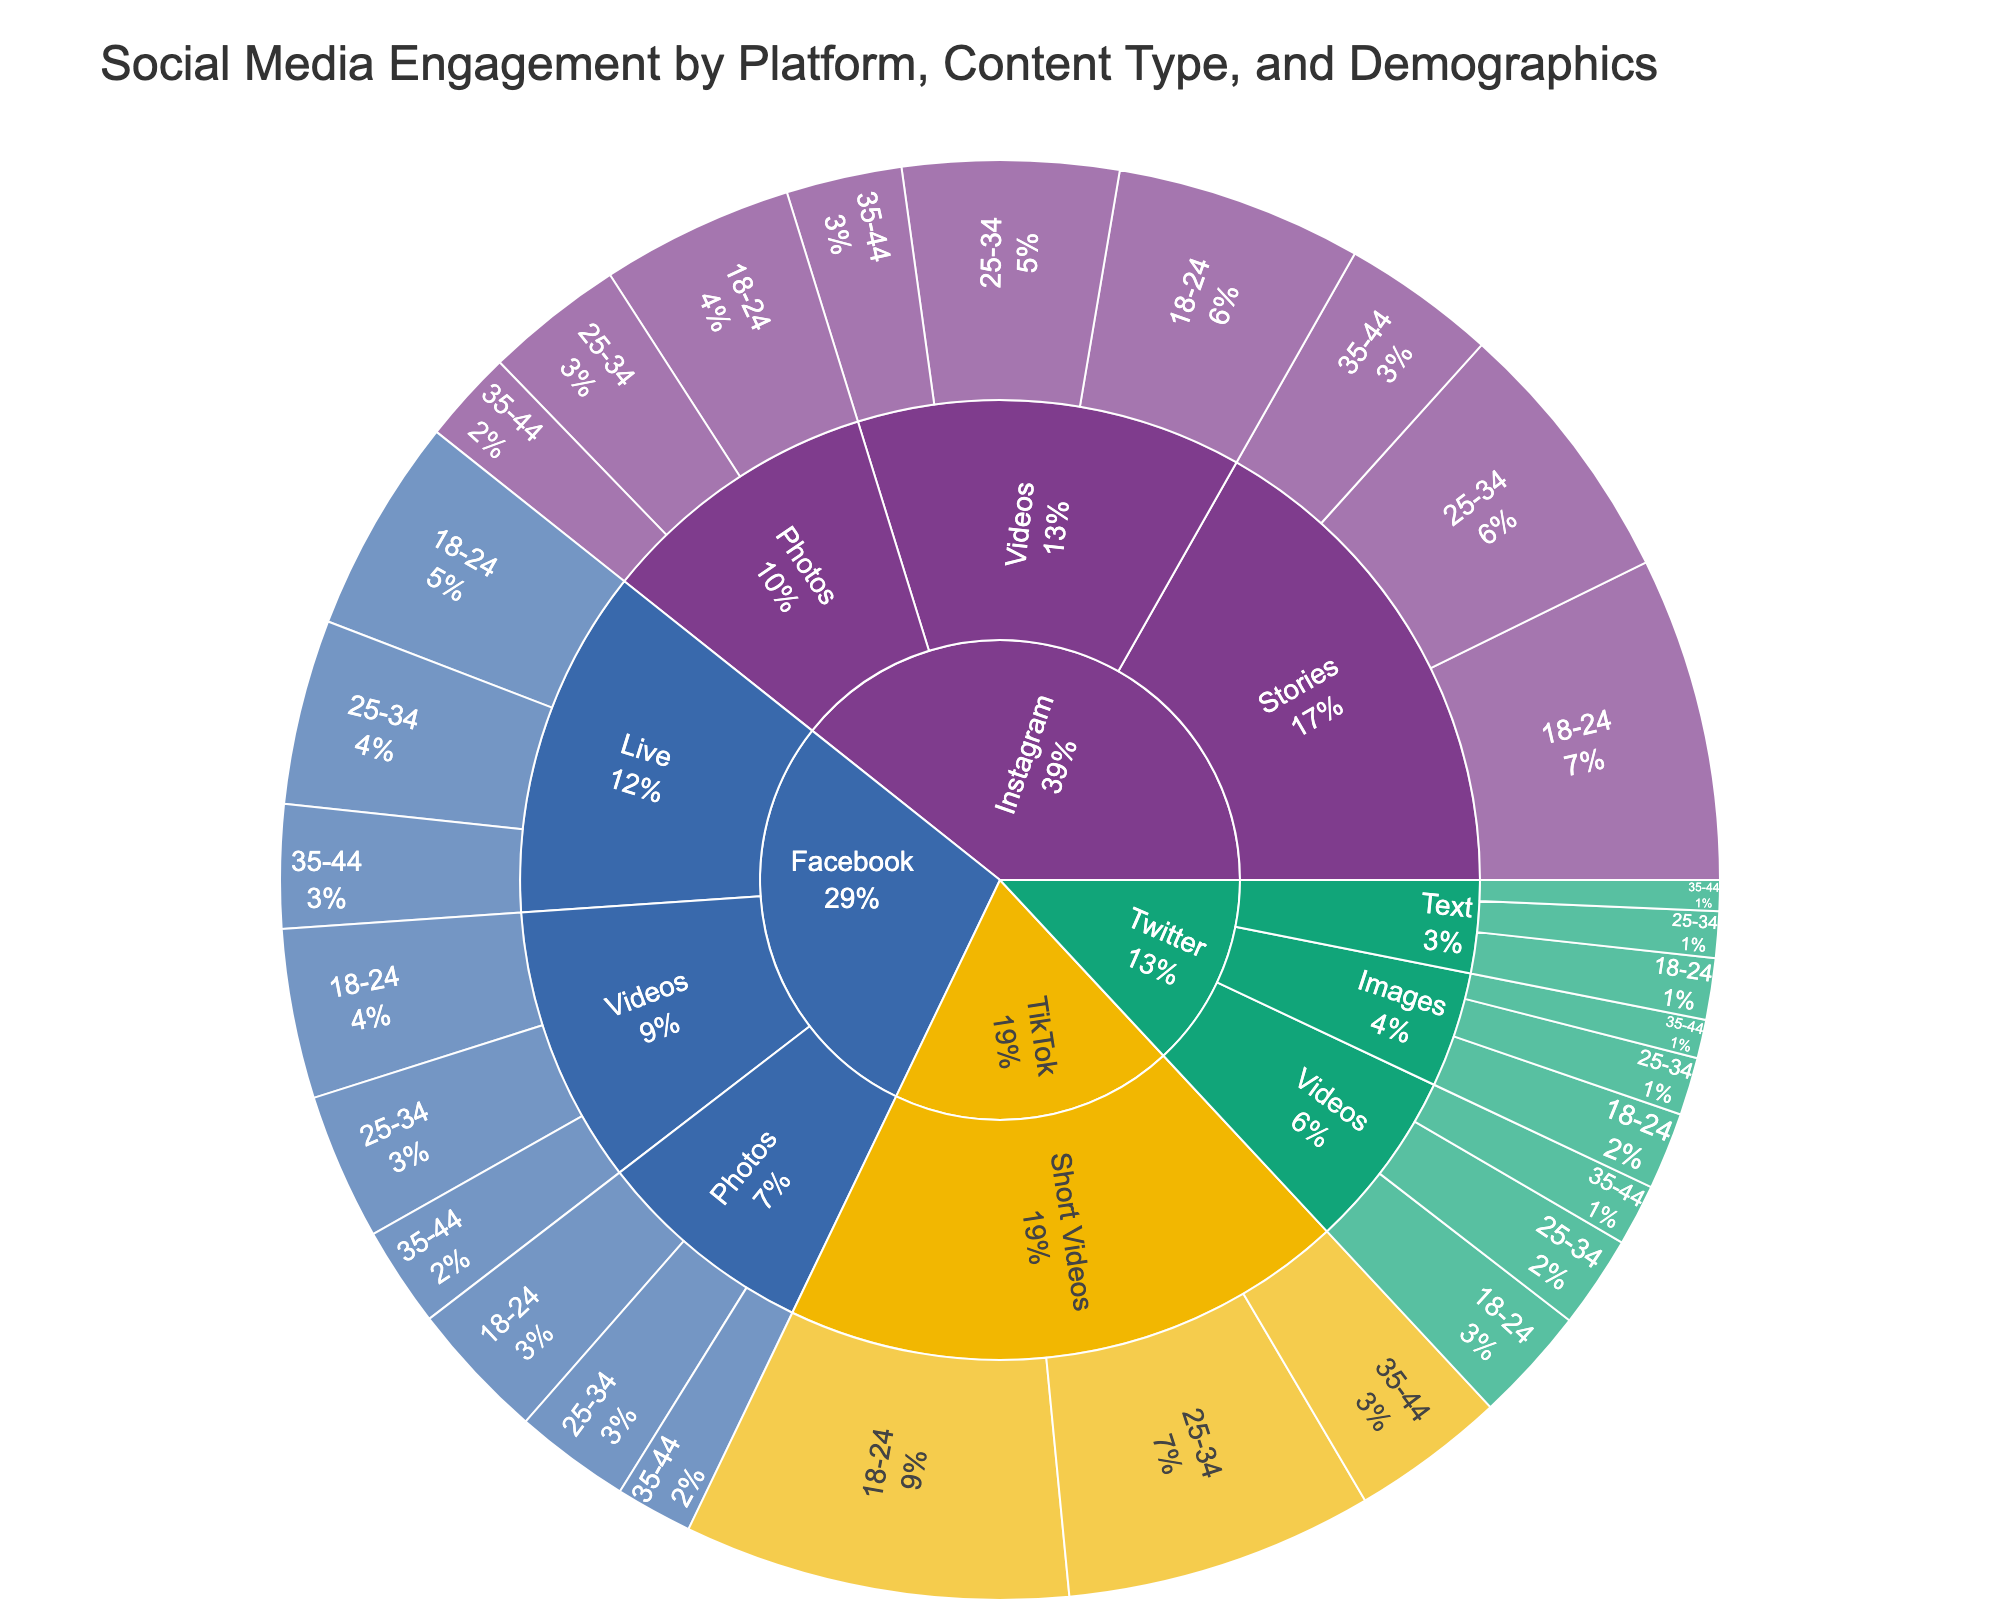what is the title of the plot? The title of the plot is located typically at the top and it provides a high-level summary of what the chart is about. In this case, it's "Social Media Engagement by Platform, Content Type, and Demographics".
Answer: Social Media Engagement by Platform, Content Type, and Demographics Which platform has the highest engagement in the 18-24 demographic? To find the platform with the highest engagement for the 18-24 demographic, look at the segments labeled for each platform and compare their engagement values. TikTok with its "Short Videos" is the segment with the highest value at 500,000.
Answer: TikTok What is the total engagement for Facebook? To find the total engagement for a specific platform like Facebook, sum the engagement values across all its content types and demographics: 180,000 (Photos) + 150,000 (Photos) + 100,000 (Photos) + 220,000 (Videos) + 190,000 (Videos) + 130,000 (Videos) + 280,000 (Live) + 240,000 (Live) + 160,000 (Live).
Answer: 1,650,000 How does the engagement for Instagram Stories compare between the 18-24 and 25-34 demographics? Compare the engagement numbers directly: Instagram Stories for 18-24 is 420,000, and for 25-34, it's 350,000. The 18-24 demographic has higher engagement.
Answer: 18-24 has 70,000 more engagement Which content type has the least engagement across all platforms for the 35-44 demographic? Check the engagement for "35-44" in each platform and content type combination: Instagram Photos (120,000), Instagram Videos (150,000), Instagram Stories (200,000), Twitter Text (40,000), Twitter Images (50,000), Twitter Videos (80,000), Facebook Photos (100,000), Facebook Videos (130,000), Facebook Live (160,000), TikTok Short Videos (200,000). Twitter Text has the least engagement with 40,000.
Answer: Twitter Text What is the engagement ratio of Instagram Videos to Instagram Photos for the 25-34 demographic? First, find the engagement for Instagram Videos (280,000) and Instagram Photos (180,000) for the 25-34 demographic. The ratio is 280,000:180,000 which simplifies to 280:180 or 14:9.
Answer: 14:9 Which platform has the highest average engagement for the 25-34 demographic? Calculate the average engagement for each platform in the 25-34 demographic. Instagram: (180,000 + 280,000 + 350,000) / 3 = 270,000; Twitter: (60,000 + 75,000 + 120,000) / 3 = 85,000; Facebook: (150,000 + 190,000 + 240,000) / 3 = 193,333; TikTok: 400,000. TikTok has the highest average engagement.
Answer: TikTok What is the percent contribution of Twitter engagement to total engagement for the 18-24 demographic? Sum Twitter's total engagement for 18-24 (80,000 + 100,000 + 150,000 = 330,000). Now, sum the total engagement across all platforms for 18-24 (250,000 + 320,000 + 420,000 + 80,000 + 100,000 + 150,000 + 180,000 + 220,000 + 280,000 + 500,000 = 2,500,000). The percentage is (330,000 / 2,500,000) * 100%.
Answer: 13.2% 